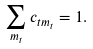Convert formula to latex. <formula><loc_0><loc_0><loc_500><loc_500>\sum _ { m _ { t } } c _ { t m _ { t } } = 1 .</formula> 